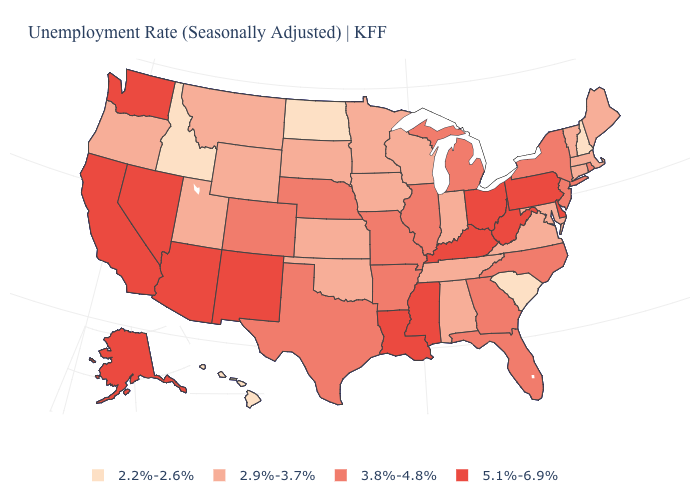Does Arizona have the highest value in the USA?
Short answer required. Yes. What is the value of Alaska?
Concise answer only. 5.1%-6.9%. Which states have the lowest value in the South?
Keep it brief. South Carolina. Which states have the lowest value in the USA?
Be succinct. Hawaii, Idaho, New Hampshire, North Dakota, South Carolina. Name the states that have a value in the range 2.2%-2.6%?
Answer briefly. Hawaii, Idaho, New Hampshire, North Dakota, South Carolina. Among the states that border Tennessee , does Arkansas have the highest value?
Short answer required. No. What is the value of Virginia?
Concise answer only. 2.9%-3.7%. What is the value of Tennessee?
Concise answer only. 2.9%-3.7%. Name the states that have a value in the range 2.2%-2.6%?
Answer briefly. Hawaii, Idaho, New Hampshire, North Dakota, South Carolina. Among the states that border New Jersey , which have the lowest value?
Be succinct. New York. What is the lowest value in the USA?
Keep it brief. 2.2%-2.6%. Is the legend a continuous bar?
Write a very short answer. No. What is the value of Kansas?
Give a very brief answer. 2.9%-3.7%. Which states have the highest value in the USA?
Quick response, please. Alaska, Arizona, California, Delaware, Kentucky, Louisiana, Mississippi, Nevada, New Mexico, Ohio, Pennsylvania, Washington, West Virginia. What is the highest value in the Northeast ?
Concise answer only. 5.1%-6.9%. 